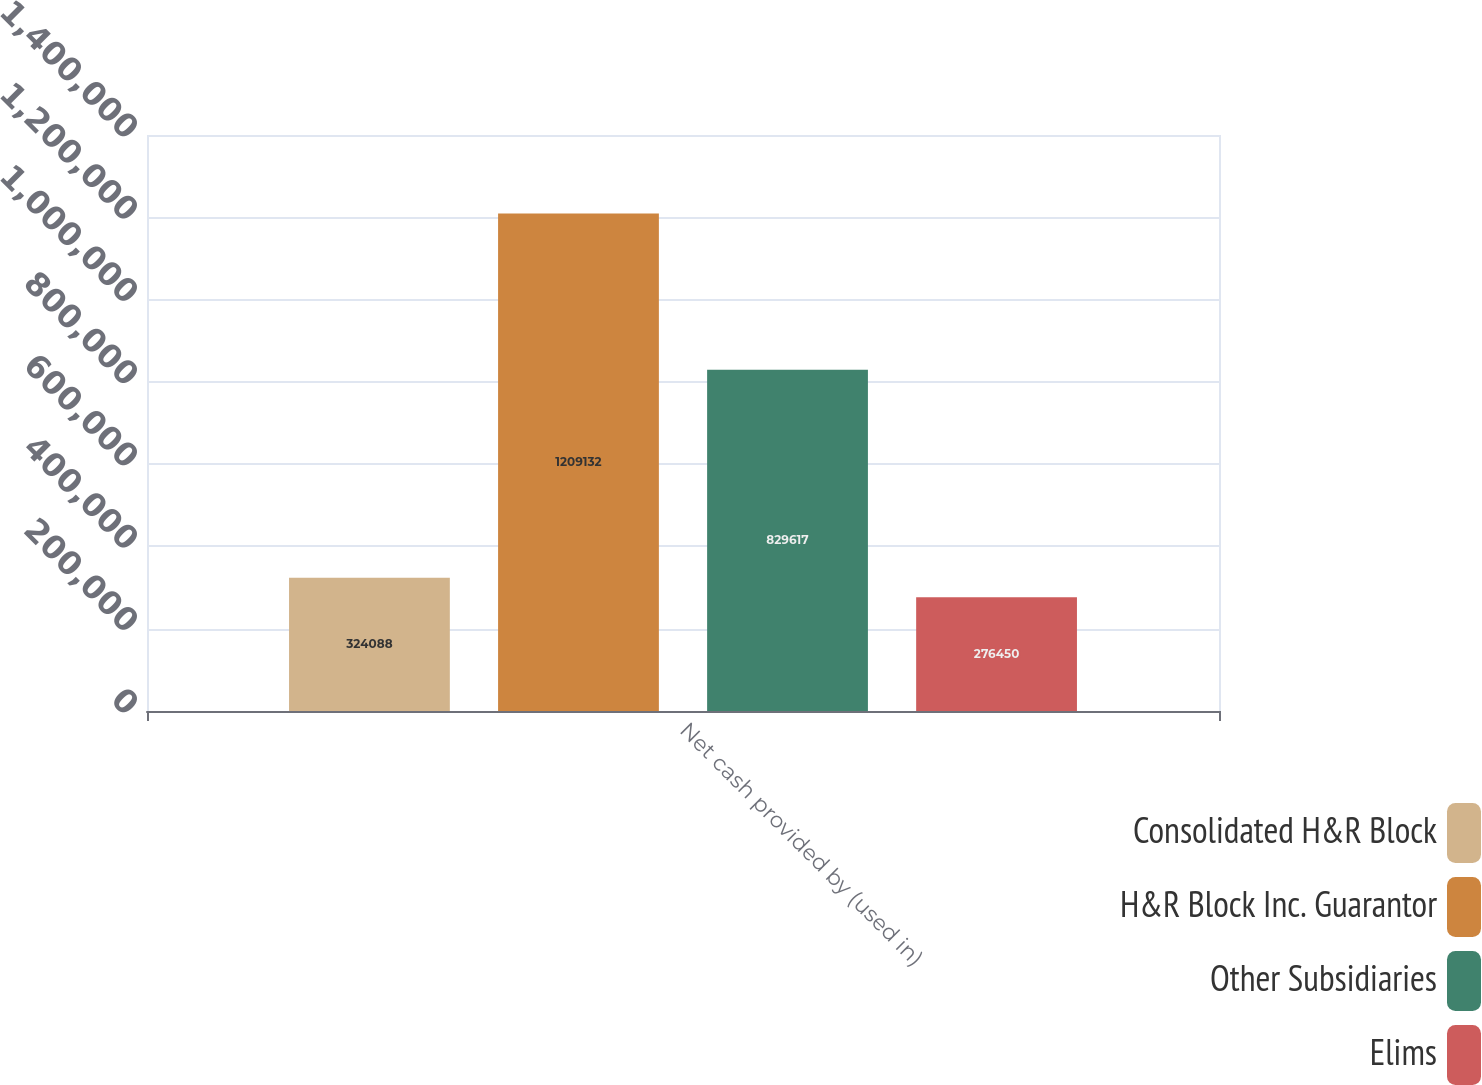Convert chart to OTSL. <chart><loc_0><loc_0><loc_500><loc_500><stacked_bar_chart><ecel><fcel>Net cash provided by (used in)<nl><fcel>Consolidated H&R Block<fcel>324088<nl><fcel>H&R Block Inc. Guarantor<fcel>1.20913e+06<nl><fcel>Other Subsidiaries<fcel>829617<nl><fcel>Elims<fcel>276450<nl></chart> 